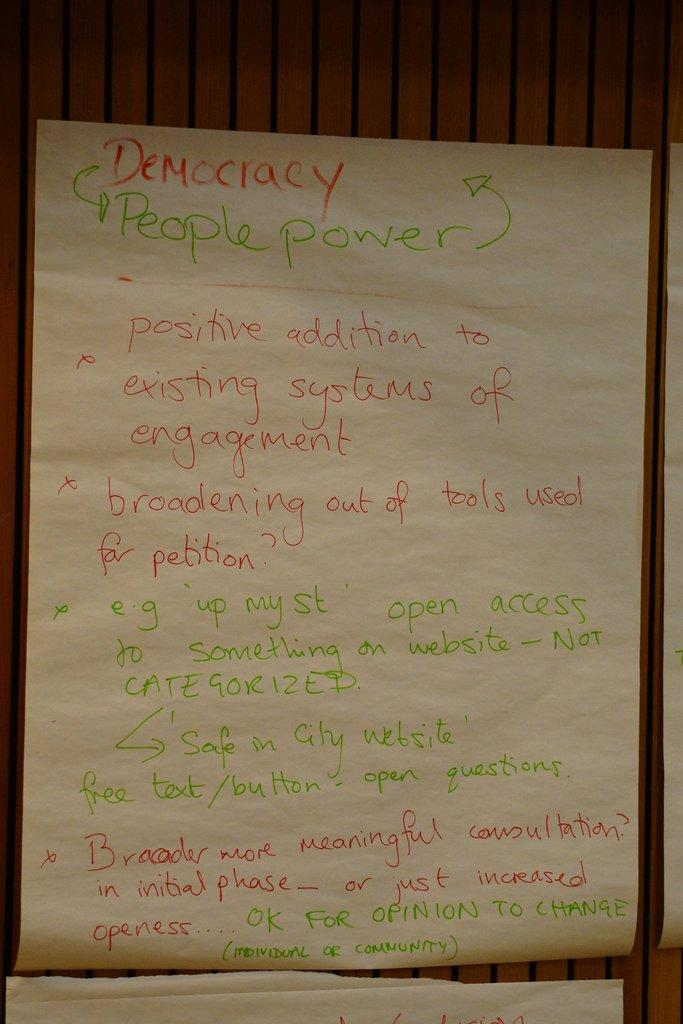<image>
Describe the image concisely. A summary of notes with the heading of "Democracy, People Power". 